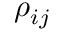<formula> <loc_0><loc_0><loc_500><loc_500>\rho _ { i j }</formula> 